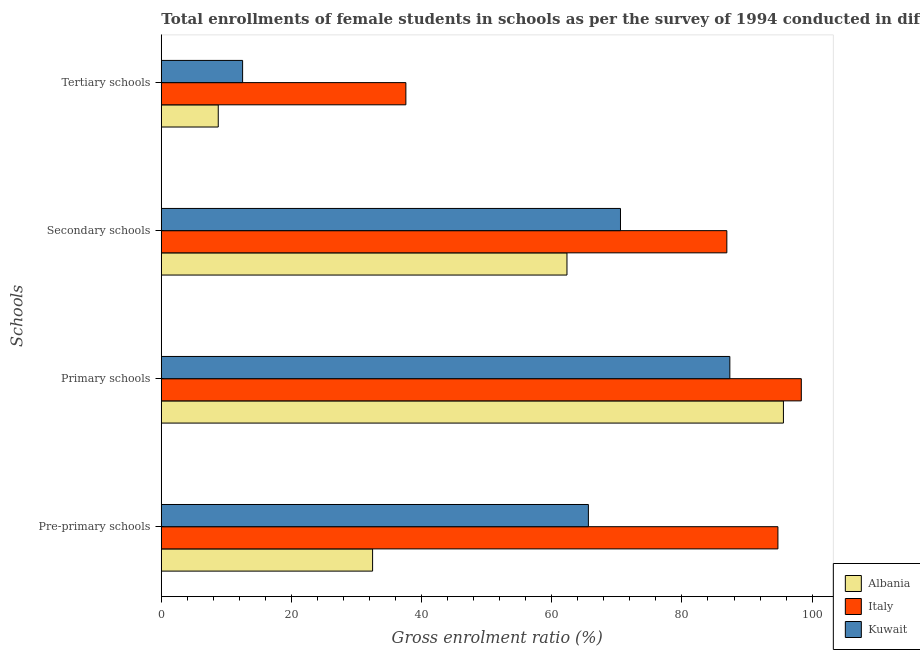How many different coloured bars are there?
Your answer should be very brief. 3. How many groups of bars are there?
Ensure brevity in your answer.  4. Are the number of bars on each tick of the Y-axis equal?
Your answer should be very brief. Yes. What is the label of the 1st group of bars from the top?
Your answer should be very brief. Tertiary schools. What is the gross enrolment ratio(female) in primary schools in Italy?
Provide a short and direct response. 98.34. Across all countries, what is the maximum gross enrolment ratio(female) in secondary schools?
Provide a succinct answer. 86.9. Across all countries, what is the minimum gross enrolment ratio(female) in tertiary schools?
Ensure brevity in your answer.  8.75. In which country was the gross enrolment ratio(female) in primary schools minimum?
Offer a very short reply. Kuwait. What is the total gross enrolment ratio(female) in primary schools in the graph?
Keep it short and to the point. 281.29. What is the difference between the gross enrolment ratio(female) in tertiary schools in Italy and that in Albania?
Keep it short and to the point. 28.83. What is the difference between the gross enrolment ratio(female) in secondary schools in Kuwait and the gross enrolment ratio(female) in tertiary schools in Albania?
Provide a short and direct response. 61.81. What is the average gross enrolment ratio(female) in pre-primary schools per country?
Your answer should be very brief. 64.28. What is the difference between the gross enrolment ratio(female) in primary schools and gross enrolment ratio(female) in pre-primary schools in Albania?
Your answer should be compact. 63.13. In how many countries, is the gross enrolment ratio(female) in secondary schools greater than 16 %?
Your answer should be very brief. 3. What is the ratio of the gross enrolment ratio(female) in secondary schools in Italy to that in Kuwait?
Your response must be concise. 1.23. Is the difference between the gross enrolment ratio(female) in pre-primary schools in Albania and Italy greater than the difference between the gross enrolment ratio(female) in tertiary schools in Albania and Italy?
Offer a very short reply. No. What is the difference between the highest and the second highest gross enrolment ratio(female) in pre-primary schools?
Your answer should be compact. 29.12. What is the difference between the highest and the lowest gross enrolment ratio(female) in tertiary schools?
Your answer should be compact. 28.83. Is the sum of the gross enrolment ratio(female) in pre-primary schools in Kuwait and Albania greater than the maximum gross enrolment ratio(female) in secondary schools across all countries?
Your response must be concise. Yes. What does the 1st bar from the top in Pre-primary schools represents?
Ensure brevity in your answer.  Kuwait. Is it the case that in every country, the sum of the gross enrolment ratio(female) in pre-primary schools and gross enrolment ratio(female) in primary schools is greater than the gross enrolment ratio(female) in secondary schools?
Provide a short and direct response. Yes. Are all the bars in the graph horizontal?
Ensure brevity in your answer.  Yes. What is the difference between two consecutive major ticks on the X-axis?
Provide a succinct answer. 20. Are the values on the major ticks of X-axis written in scientific E-notation?
Offer a terse response. No. Does the graph contain grids?
Your response must be concise. No. Where does the legend appear in the graph?
Offer a terse response. Bottom right. What is the title of the graph?
Make the answer very short. Total enrollments of female students in schools as per the survey of 1994 conducted in different countries. What is the label or title of the Y-axis?
Keep it short and to the point. Schools. What is the Gross enrolment ratio (%) in Albania in Pre-primary schools?
Provide a succinct answer. 32.47. What is the Gross enrolment ratio (%) of Italy in Pre-primary schools?
Provide a succinct answer. 94.75. What is the Gross enrolment ratio (%) in Kuwait in Pre-primary schools?
Make the answer very short. 65.62. What is the Gross enrolment ratio (%) of Albania in Primary schools?
Make the answer very short. 95.59. What is the Gross enrolment ratio (%) in Italy in Primary schools?
Provide a succinct answer. 98.34. What is the Gross enrolment ratio (%) of Kuwait in Primary schools?
Give a very brief answer. 87.36. What is the Gross enrolment ratio (%) of Albania in Secondary schools?
Provide a short and direct response. 62.33. What is the Gross enrolment ratio (%) of Italy in Secondary schools?
Give a very brief answer. 86.9. What is the Gross enrolment ratio (%) in Kuwait in Secondary schools?
Your answer should be compact. 70.55. What is the Gross enrolment ratio (%) of Albania in Tertiary schools?
Your answer should be very brief. 8.75. What is the Gross enrolment ratio (%) in Italy in Tertiary schools?
Offer a terse response. 37.58. What is the Gross enrolment ratio (%) in Kuwait in Tertiary schools?
Make the answer very short. 12.49. Across all Schools, what is the maximum Gross enrolment ratio (%) in Albania?
Your response must be concise. 95.59. Across all Schools, what is the maximum Gross enrolment ratio (%) in Italy?
Provide a succinct answer. 98.34. Across all Schools, what is the maximum Gross enrolment ratio (%) in Kuwait?
Provide a short and direct response. 87.36. Across all Schools, what is the minimum Gross enrolment ratio (%) in Albania?
Offer a very short reply. 8.75. Across all Schools, what is the minimum Gross enrolment ratio (%) in Italy?
Offer a terse response. 37.58. Across all Schools, what is the minimum Gross enrolment ratio (%) in Kuwait?
Provide a short and direct response. 12.49. What is the total Gross enrolment ratio (%) of Albania in the graph?
Give a very brief answer. 199.14. What is the total Gross enrolment ratio (%) of Italy in the graph?
Provide a succinct answer. 317.57. What is the total Gross enrolment ratio (%) of Kuwait in the graph?
Your answer should be very brief. 236.03. What is the difference between the Gross enrolment ratio (%) of Albania in Pre-primary schools and that in Primary schools?
Provide a succinct answer. -63.13. What is the difference between the Gross enrolment ratio (%) of Italy in Pre-primary schools and that in Primary schools?
Your answer should be compact. -3.6. What is the difference between the Gross enrolment ratio (%) in Kuwait in Pre-primary schools and that in Primary schools?
Provide a succinct answer. -21.73. What is the difference between the Gross enrolment ratio (%) of Albania in Pre-primary schools and that in Secondary schools?
Keep it short and to the point. -29.87. What is the difference between the Gross enrolment ratio (%) in Italy in Pre-primary schools and that in Secondary schools?
Keep it short and to the point. 7.85. What is the difference between the Gross enrolment ratio (%) of Kuwait in Pre-primary schools and that in Secondary schools?
Offer a very short reply. -4.93. What is the difference between the Gross enrolment ratio (%) of Albania in Pre-primary schools and that in Tertiary schools?
Ensure brevity in your answer.  23.72. What is the difference between the Gross enrolment ratio (%) of Italy in Pre-primary schools and that in Tertiary schools?
Your response must be concise. 57.17. What is the difference between the Gross enrolment ratio (%) in Kuwait in Pre-primary schools and that in Tertiary schools?
Your answer should be very brief. 53.13. What is the difference between the Gross enrolment ratio (%) in Albania in Primary schools and that in Secondary schools?
Your answer should be compact. 33.26. What is the difference between the Gross enrolment ratio (%) of Italy in Primary schools and that in Secondary schools?
Your response must be concise. 11.44. What is the difference between the Gross enrolment ratio (%) in Kuwait in Primary schools and that in Secondary schools?
Provide a succinct answer. 16.8. What is the difference between the Gross enrolment ratio (%) in Albania in Primary schools and that in Tertiary schools?
Your answer should be very brief. 86.84. What is the difference between the Gross enrolment ratio (%) in Italy in Primary schools and that in Tertiary schools?
Keep it short and to the point. 60.76. What is the difference between the Gross enrolment ratio (%) in Kuwait in Primary schools and that in Tertiary schools?
Your answer should be very brief. 74.87. What is the difference between the Gross enrolment ratio (%) of Albania in Secondary schools and that in Tertiary schools?
Your response must be concise. 53.58. What is the difference between the Gross enrolment ratio (%) in Italy in Secondary schools and that in Tertiary schools?
Offer a very short reply. 49.32. What is the difference between the Gross enrolment ratio (%) of Kuwait in Secondary schools and that in Tertiary schools?
Provide a short and direct response. 58.06. What is the difference between the Gross enrolment ratio (%) in Albania in Pre-primary schools and the Gross enrolment ratio (%) in Italy in Primary schools?
Keep it short and to the point. -65.88. What is the difference between the Gross enrolment ratio (%) of Albania in Pre-primary schools and the Gross enrolment ratio (%) of Kuwait in Primary schools?
Your answer should be compact. -54.89. What is the difference between the Gross enrolment ratio (%) in Italy in Pre-primary schools and the Gross enrolment ratio (%) in Kuwait in Primary schools?
Ensure brevity in your answer.  7.39. What is the difference between the Gross enrolment ratio (%) of Albania in Pre-primary schools and the Gross enrolment ratio (%) of Italy in Secondary schools?
Provide a short and direct response. -54.43. What is the difference between the Gross enrolment ratio (%) of Albania in Pre-primary schools and the Gross enrolment ratio (%) of Kuwait in Secondary schools?
Your response must be concise. -38.09. What is the difference between the Gross enrolment ratio (%) of Italy in Pre-primary schools and the Gross enrolment ratio (%) of Kuwait in Secondary schools?
Offer a very short reply. 24.19. What is the difference between the Gross enrolment ratio (%) in Albania in Pre-primary schools and the Gross enrolment ratio (%) in Italy in Tertiary schools?
Your answer should be very brief. -5.11. What is the difference between the Gross enrolment ratio (%) of Albania in Pre-primary schools and the Gross enrolment ratio (%) of Kuwait in Tertiary schools?
Keep it short and to the point. 19.97. What is the difference between the Gross enrolment ratio (%) of Italy in Pre-primary schools and the Gross enrolment ratio (%) of Kuwait in Tertiary schools?
Ensure brevity in your answer.  82.25. What is the difference between the Gross enrolment ratio (%) of Albania in Primary schools and the Gross enrolment ratio (%) of Italy in Secondary schools?
Ensure brevity in your answer.  8.69. What is the difference between the Gross enrolment ratio (%) in Albania in Primary schools and the Gross enrolment ratio (%) in Kuwait in Secondary schools?
Your response must be concise. 25.04. What is the difference between the Gross enrolment ratio (%) of Italy in Primary schools and the Gross enrolment ratio (%) of Kuwait in Secondary schools?
Offer a very short reply. 27.79. What is the difference between the Gross enrolment ratio (%) in Albania in Primary schools and the Gross enrolment ratio (%) in Italy in Tertiary schools?
Offer a very short reply. 58.01. What is the difference between the Gross enrolment ratio (%) of Albania in Primary schools and the Gross enrolment ratio (%) of Kuwait in Tertiary schools?
Provide a short and direct response. 83.1. What is the difference between the Gross enrolment ratio (%) of Italy in Primary schools and the Gross enrolment ratio (%) of Kuwait in Tertiary schools?
Ensure brevity in your answer.  85.85. What is the difference between the Gross enrolment ratio (%) in Albania in Secondary schools and the Gross enrolment ratio (%) in Italy in Tertiary schools?
Your answer should be compact. 24.75. What is the difference between the Gross enrolment ratio (%) in Albania in Secondary schools and the Gross enrolment ratio (%) in Kuwait in Tertiary schools?
Keep it short and to the point. 49.84. What is the difference between the Gross enrolment ratio (%) of Italy in Secondary schools and the Gross enrolment ratio (%) of Kuwait in Tertiary schools?
Provide a short and direct response. 74.41. What is the average Gross enrolment ratio (%) in Albania per Schools?
Your answer should be compact. 49.78. What is the average Gross enrolment ratio (%) of Italy per Schools?
Ensure brevity in your answer.  79.39. What is the average Gross enrolment ratio (%) of Kuwait per Schools?
Your answer should be very brief. 59.01. What is the difference between the Gross enrolment ratio (%) in Albania and Gross enrolment ratio (%) in Italy in Pre-primary schools?
Keep it short and to the point. -62.28. What is the difference between the Gross enrolment ratio (%) of Albania and Gross enrolment ratio (%) of Kuwait in Pre-primary schools?
Provide a succinct answer. -33.16. What is the difference between the Gross enrolment ratio (%) of Italy and Gross enrolment ratio (%) of Kuwait in Pre-primary schools?
Your answer should be compact. 29.12. What is the difference between the Gross enrolment ratio (%) of Albania and Gross enrolment ratio (%) of Italy in Primary schools?
Keep it short and to the point. -2.75. What is the difference between the Gross enrolment ratio (%) of Albania and Gross enrolment ratio (%) of Kuwait in Primary schools?
Provide a short and direct response. 8.23. What is the difference between the Gross enrolment ratio (%) in Italy and Gross enrolment ratio (%) in Kuwait in Primary schools?
Ensure brevity in your answer.  10.98. What is the difference between the Gross enrolment ratio (%) in Albania and Gross enrolment ratio (%) in Italy in Secondary schools?
Offer a terse response. -24.57. What is the difference between the Gross enrolment ratio (%) of Albania and Gross enrolment ratio (%) of Kuwait in Secondary schools?
Offer a very short reply. -8.22. What is the difference between the Gross enrolment ratio (%) of Italy and Gross enrolment ratio (%) of Kuwait in Secondary schools?
Offer a very short reply. 16.34. What is the difference between the Gross enrolment ratio (%) in Albania and Gross enrolment ratio (%) in Italy in Tertiary schools?
Your response must be concise. -28.83. What is the difference between the Gross enrolment ratio (%) in Albania and Gross enrolment ratio (%) in Kuwait in Tertiary schools?
Your response must be concise. -3.74. What is the difference between the Gross enrolment ratio (%) in Italy and Gross enrolment ratio (%) in Kuwait in Tertiary schools?
Make the answer very short. 25.09. What is the ratio of the Gross enrolment ratio (%) in Albania in Pre-primary schools to that in Primary schools?
Keep it short and to the point. 0.34. What is the ratio of the Gross enrolment ratio (%) in Italy in Pre-primary schools to that in Primary schools?
Provide a short and direct response. 0.96. What is the ratio of the Gross enrolment ratio (%) in Kuwait in Pre-primary schools to that in Primary schools?
Your answer should be very brief. 0.75. What is the ratio of the Gross enrolment ratio (%) of Albania in Pre-primary schools to that in Secondary schools?
Offer a very short reply. 0.52. What is the ratio of the Gross enrolment ratio (%) of Italy in Pre-primary schools to that in Secondary schools?
Provide a succinct answer. 1.09. What is the ratio of the Gross enrolment ratio (%) of Kuwait in Pre-primary schools to that in Secondary schools?
Your answer should be compact. 0.93. What is the ratio of the Gross enrolment ratio (%) of Albania in Pre-primary schools to that in Tertiary schools?
Your answer should be very brief. 3.71. What is the ratio of the Gross enrolment ratio (%) in Italy in Pre-primary schools to that in Tertiary schools?
Provide a succinct answer. 2.52. What is the ratio of the Gross enrolment ratio (%) in Kuwait in Pre-primary schools to that in Tertiary schools?
Provide a succinct answer. 5.25. What is the ratio of the Gross enrolment ratio (%) of Albania in Primary schools to that in Secondary schools?
Offer a very short reply. 1.53. What is the ratio of the Gross enrolment ratio (%) of Italy in Primary schools to that in Secondary schools?
Provide a succinct answer. 1.13. What is the ratio of the Gross enrolment ratio (%) in Kuwait in Primary schools to that in Secondary schools?
Ensure brevity in your answer.  1.24. What is the ratio of the Gross enrolment ratio (%) of Albania in Primary schools to that in Tertiary schools?
Make the answer very short. 10.93. What is the ratio of the Gross enrolment ratio (%) in Italy in Primary schools to that in Tertiary schools?
Your answer should be very brief. 2.62. What is the ratio of the Gross enrolment ratio (%) in Kuwait in Primary schools to that in Tertiary schools?
Your answer should be compact. 6.99. What is the ratio of the Gross enrolment ratio (%) in Albania in Secondary schools to that in Tertiary schools?
Offer a terse response. 7.13. What is the ratio of the Gross enrolment ratio (%) in Italy in Secondary schools to that in Tertiary schools?
Provide a short and direct response. 2.31. What is the ratio of the Gross enrolment ratio (%) in Kuwait in Secondary schools to that in Tertiary schools?
Provide a succinct answer. 5.65. What is the difference between the highest and the second highest Gross enrolment ratio (%) in Albania?
Make the answer very short. 33.26. What is the difference between the highest and the second highest Gross enrolment ratio (%) of Italy?
Your response must be concise. 3.6. What is the difference between the highest and the second highest Gross enrolment ratio (%) in Kuwait?
Make the answer very short. 16.8. What is the difference between the highest and the lowest Gross enrolment ratio (%) in Albania?
Provide a short and direct response. 86.84. What is the difference between the highest and the lowest Gross enrolment ratio (%) in Italy?
Keep it short and to the point. 60.76. What is the difference between the highest and the lowest Gross enrolment ratio (%) of Kuwait?
Keep it short and to the point. 74.87. 